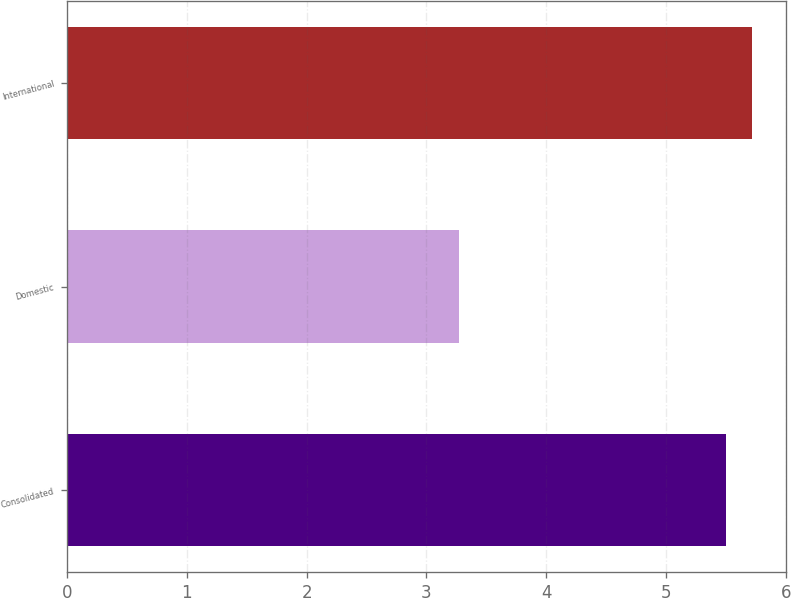Convert chart to OTSL. <chart><loc_0><loc_0><loc_500><loc_500><bar_chart><fcel>Consolidated<fcel>Domestic<fcel>International<nl><fcel>5.5<fcel>3.27<fcel>5.72<nl></chart> 